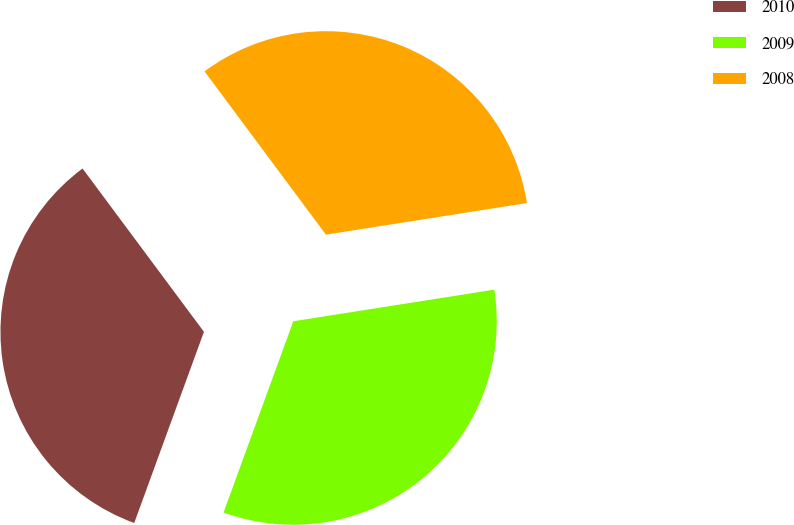<chart> <loc_0><loc_0><loc_500><loc_500><pie_chart><fcel>2010<fcel>2009<fcel>2008<nl><fcel>34.26%<fcel>33.05%<fcel>32.69%<nl></chart> 